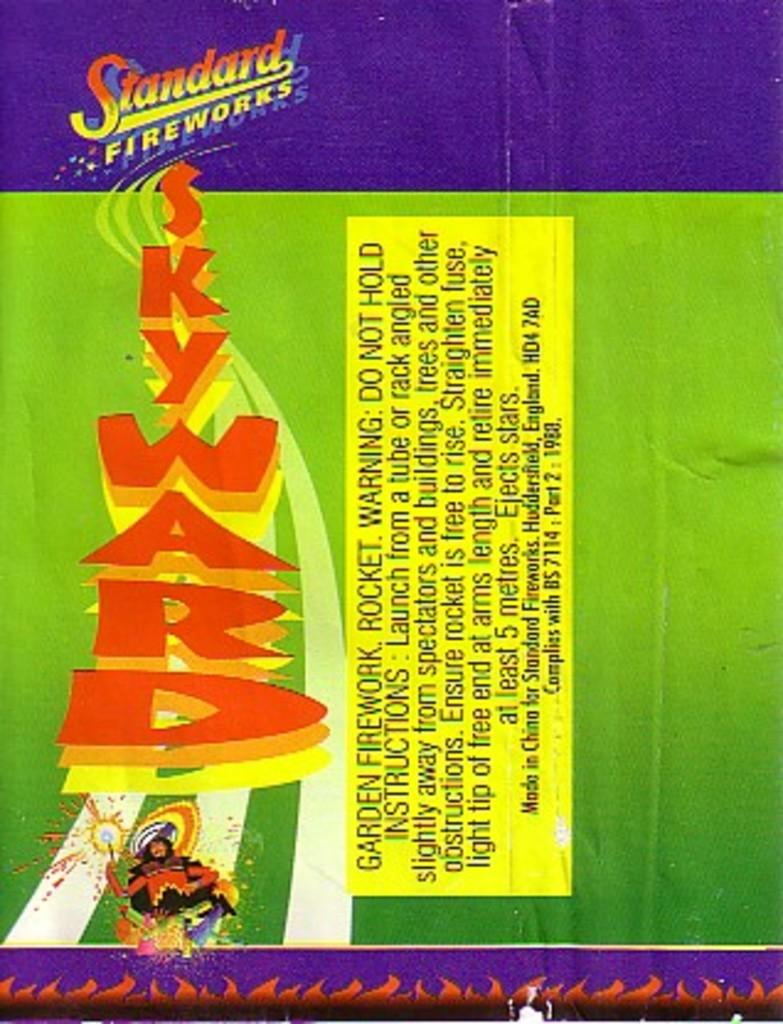<image>
Offer a succinct explanation of the picture presented. A purple and green package of Stanford Fireworks 